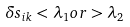<formula> <loc_0><loc_0><loc_500><loc_500>\delta s _ { i k } < \lambda _ { 1 } o r > \lambda _ { 2 }</formula> 